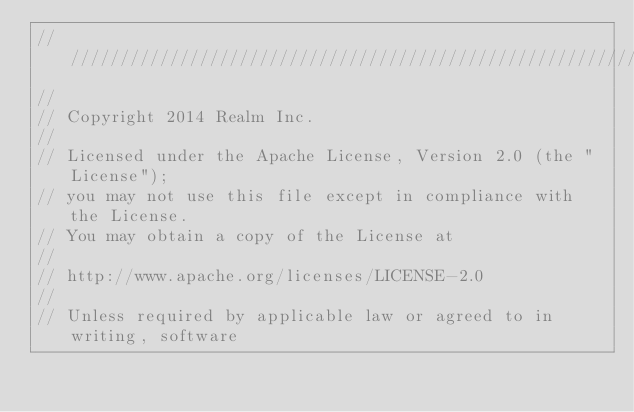Convert code to text. <code><loc_0><loc_0><loc_500><loc_500><_ObjectiveC_>////////////////////////////////////////////////////////////////////////////
//
// Copyright 2014 Realm Inc.
//
// Licensed under the Apache License, Version 2.0 (the "License");
// you may not use this file except in compliance with the License.
// You may obtain a copy of the License at
//
// http://www.apache.org/licenses/LICENSE-2.0
//
// Unless required by applicable law or agreed to in writing, software</code> 